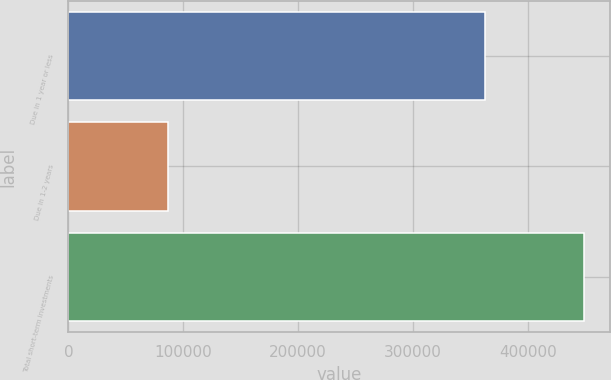<chart> <loc_0><loc_0><loc_500><loc_500><bar_chart><fcel>Due in 1 year or less<fcel>Due in 1-2 years<fcel>Total short-term investments<nl><fcel>362338<fcel>86594<fcel>448932<nl></chart> 